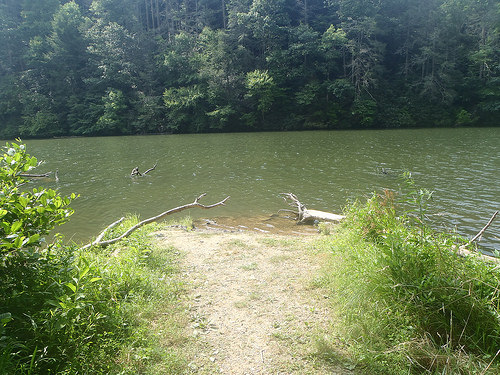<image>
Is there a water behind the grass? Yes. From this viewpoint, the water is positioned behind the grass, with the grass partially or fully occluding the water. Is there a plant under the water? No. The plant is not positioned under the water. The vertical relationship between these objects is different. 